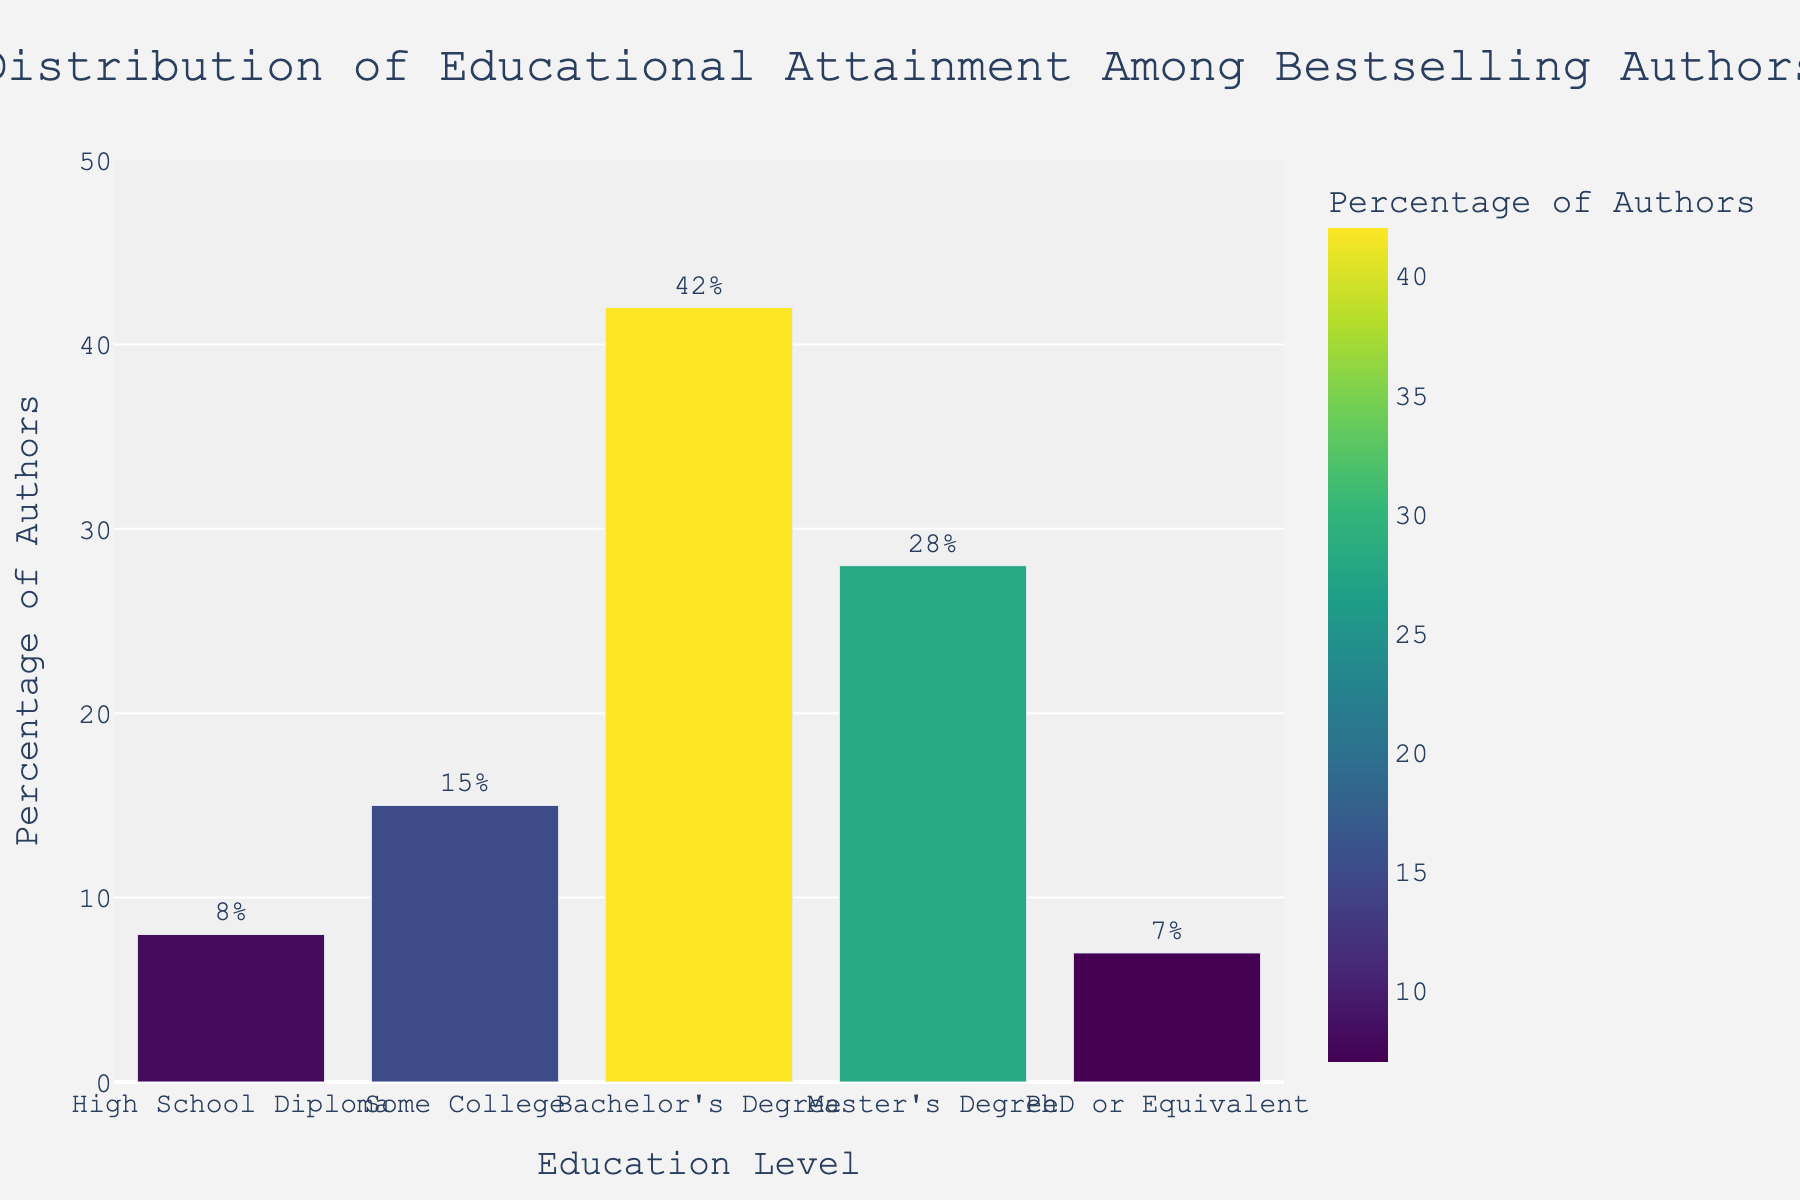What percentage of bestselling authors have at least a Bachelor's Degree? Sum the percentages of Bachelor's Degree (42%), Master's Degree (28%), and PhD or Equivalent (7%). Thus, 42 + 28 + 7 = 77%.
Answer: 77% What is the difference in percentage between authors with a Master's Degree and those with a High School Diploma? Subtract the percentage of authors with a High School Diploma (8%) from those with a Master's Degree (28%). Thus, 28 - 8 = 20%.
Answer: 20% Which education level has the highest percentage of bestselling authors? The highest bar on the chart represents the Bachelor's Degree with 42%.
Answer: Bachelor's Degree How does the percentage of authors with some college compare to those with a PhD? Authors with some college represent 15%, while those with a PhD (or equivalent) represent 7%. 15% is greater than 7%.
Answer: More Which two education levels combined make up more than half of the authors? Combine Bachelor's Degree (42%) and Master's Degree (28%). Thus, 42 + 28 = 70%, which is more than half (50%).
Answer: Bachelor's Degree and Master's Degree What is the average percentage of authors in the categories that do not have a degree (High School Diploma and Some College)? Average the percentages of High School Diploma (8%) and Some College (15%). (8 + 15) / 2 = 11.5%.
Answer: 11.5% Are PhD and High School Diploma categories combined greater or less than the Master's Degree category? Combine PhD (7%) and High School Diploma (8%). Then compare with Master's Degree (28%). Thus, 7 + 8 = 15%, which is less than 28%.
Answer: Less How much more common is a Bachelor's Degree compared to a PhD? Subtract the percentage of PhD (7%) from Bachelor's Degree (42%). Thus, 42 - 7 = 35%.
Answer: 35% Which education level is represented by the shortest bar in the chart? The shortest bar corresponds to PhD or Equivalent with 7%.
Answer: PhD or Equivalent What is the combined percentage of authors with a High School Diploma or Some College? Add the percentages of High School Diploma (8%) and Some College (15%). Thus, 8 + 15 = 23%.
Answer: 23% 